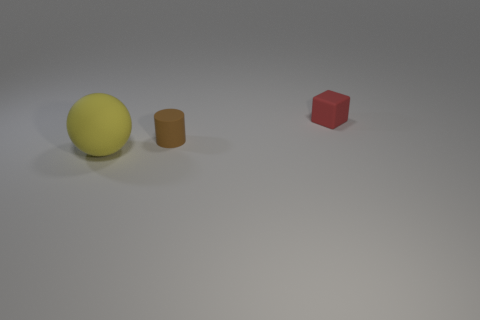What possible uses could these objects have? The yellow sphere could be a child's toy ball, suitable for indoor play. The brown cylinder might be a container or a simple prop for educational purposes, such as teaching geometry. The red cube could also serve a similar educational role or be a building block for creative play. 